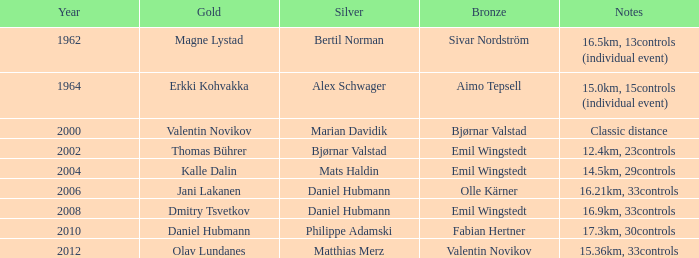WHAT YEAR HAS A BRONZE OF VALENTIN NOVIKOV? 2012.0. 